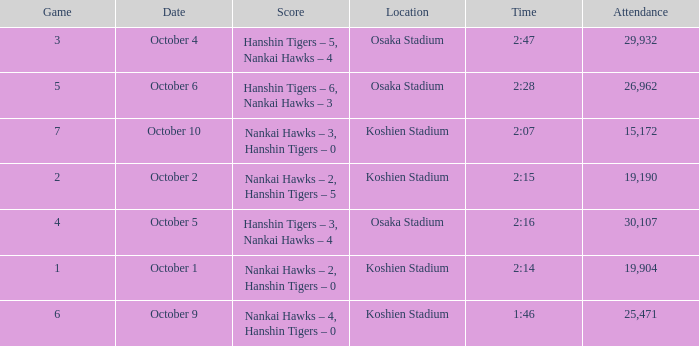Which Score has a Time of 2:28? Hanshin Tigers – 6, Nankai Hawks – 3. 